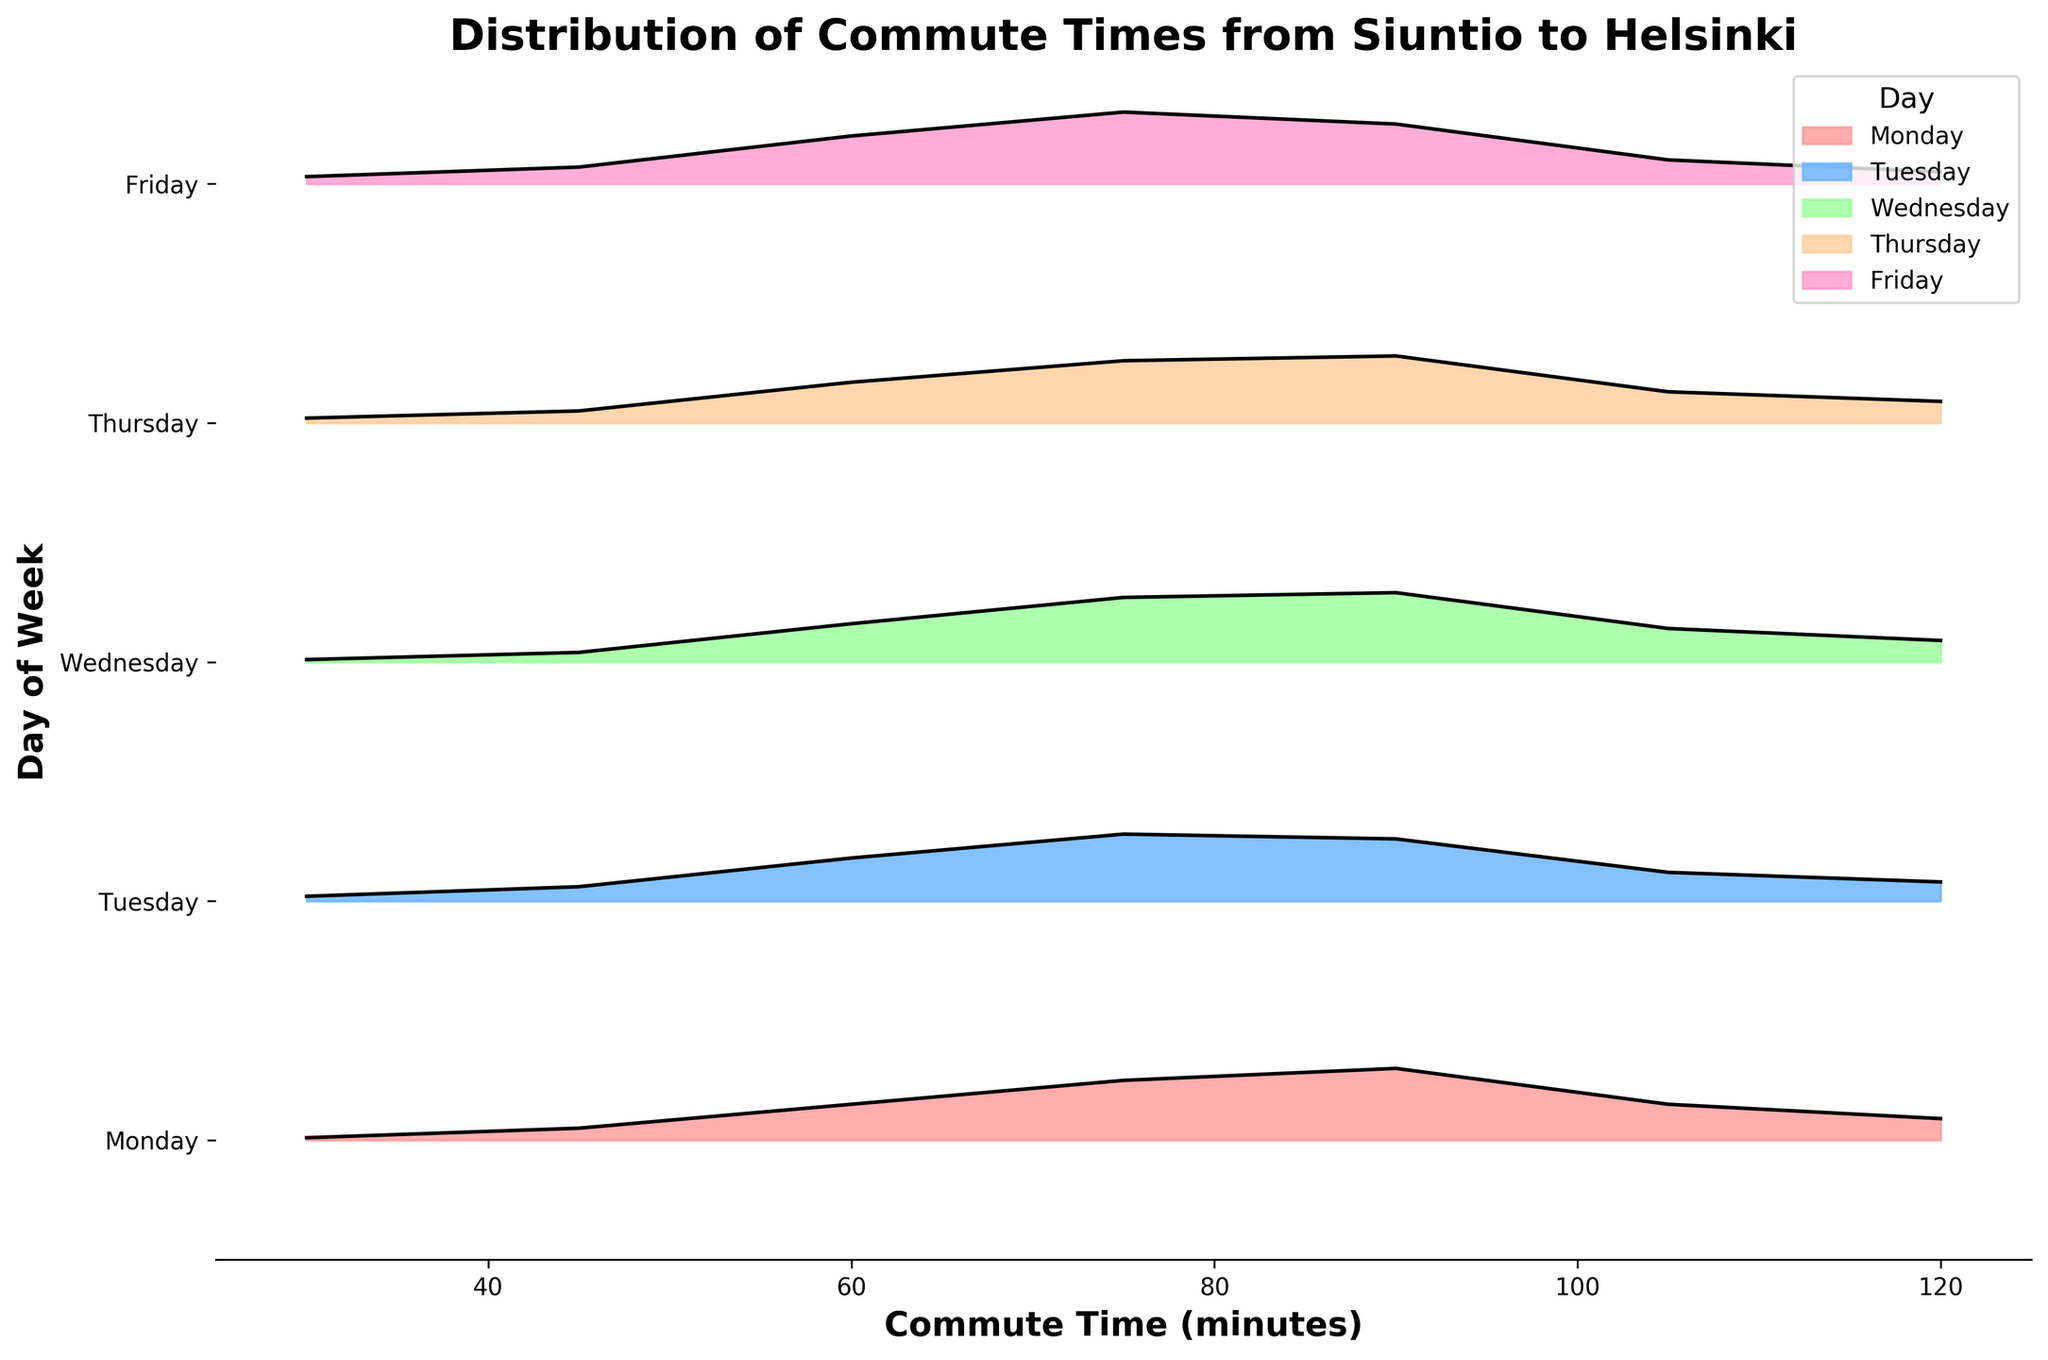What is the title of the figure? The title of the figure is displayed at the top of the plot. It generally summarizes what the figure is illustrating.
Answer: Distribution of Commute Times from Siuntio to Helsinki What are the labels on the x and y axes? The labels are provided near the axes. The x-axis generally indicates some measurement or category, and the y-axis typically shows another variable, usually categorical for a Ridgeline plot.
Answer: The x-axis is labeled ‘Commute Time (minutes)’ and the y-axis is labeled ‘Day of Week’ Which day has the highest density at a 90-minute commute time? To find this, we need to look at the height of the density curve on the 90-minute mark on the x-axis for all the days. The tallest curve indicates the highest density.
Answer: Monday What color represents Friday in the plot? Each day has a different color, represented in the plot legend. The legend shows which color corresponds to Friday.
Answer: Light pink Which day shows the widest spread of commute times? The spread can be seen by the range of times from where the density appears to where it ends. Compare the ranges across the days.
Answer: Monday Compare the density at 60 minutes on Monday and Friday. Which one is higher? By looking at the height of the density curves for both Monday and Friday at the 60-minute mark, the curve with greater height represents a higher density.
Answer: Friday Which day of the week has the lowest density at 75 minutes? By examining the 75-minute mark and comparing the height of the density curves across each day, we can determine which one is the lowest.
Answer: Friday What is the general trend in commute times from Monday to Friday? To identify the trend, observe how the density distributions shift from Monday to Friday, looking at both the spread and peak of the curves.
Answer: Densities generally shift towards shorter commute times as the week progresses, with Monday having longer commutes What is the average peak density for commute times on Tuesday? To find this, identify the peak densities for Tuesday at different commute times, sum them up, and divide by the number of peak values considered.
Answer: 0.25 How does the commute time distribution on Wednesday compare to Tuesday? Compare the shapes, spread, and peak densities of the distributions for Wednesday and Tuesday.
Answer: Wednesday has slightly lower peak densities than Tuesday but similar spread and shape What is the commute time associated with the peak density on Thursday? Observe the Thursday curve and identify the time value on the x-axis where the density reaches its maximum height.
Answer: 90 minutes 